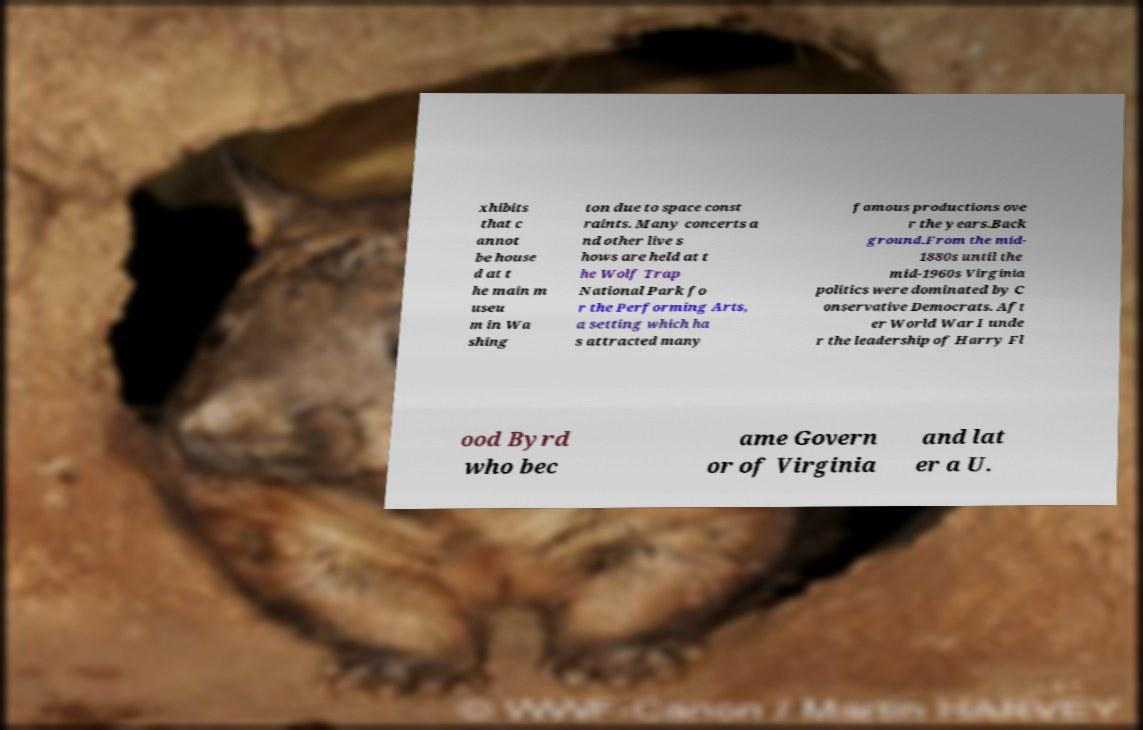Could you extract and type out the text from this image? xhibits that c annot be house d at t he main m useu m in Wa shing ton due to space const raints. Many concerts a nd other live s hows are held at t he Wolf Trap National Park fo r the Performing Arts, a setting which ha s attracted many famous productions ove r the years.Back ground.From the mid- 1880s until the mid-1960s Virginia politics were dominated by C onservative Democrats. Aft er World War I unde r the leadership of Harry Fl ood Byrd who bec ame Govern or of Virginia and lat er a U. 